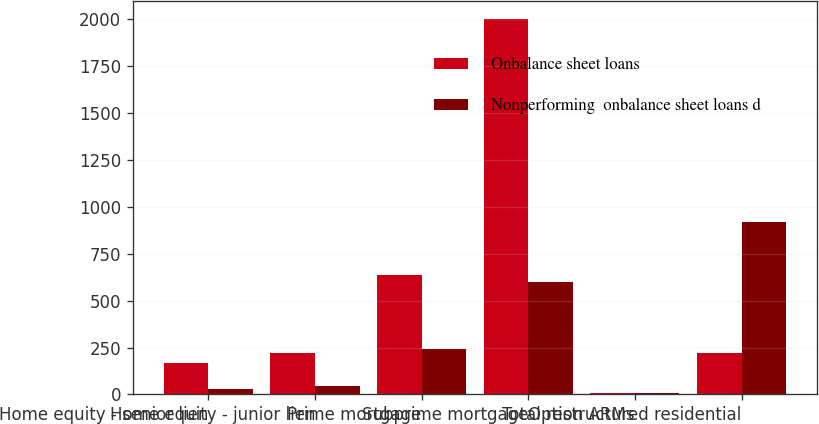Convert chart to OTSL. <chart><loc_0><loc_0><loc_500><loc_500><stacked_bar_chart><ecel><fcel>Home equity - senior lien<fcel>Home equity - junior lien<fcel>Prime mortgage<fcel>Subprime mortgage<fcel>Option ARMs<fcel>Total restructured residential<nl><fcel>Onbalance sheet loans<fcel>168<fcel>222<fcel>634<fcel>1998<fcel>8<fcel>222<nl><fcel>Nonperforming  onbalance sheet loans d<fcel>30<fcel>43<fcel>243<fcel>598<fcel>6<fcel>920<nl></chart> 